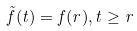<formula> <loc_0><loc_0><loc_500><loc_500>\tilde { f } ( t ) = f ( r ) , t \geq r</formula> 